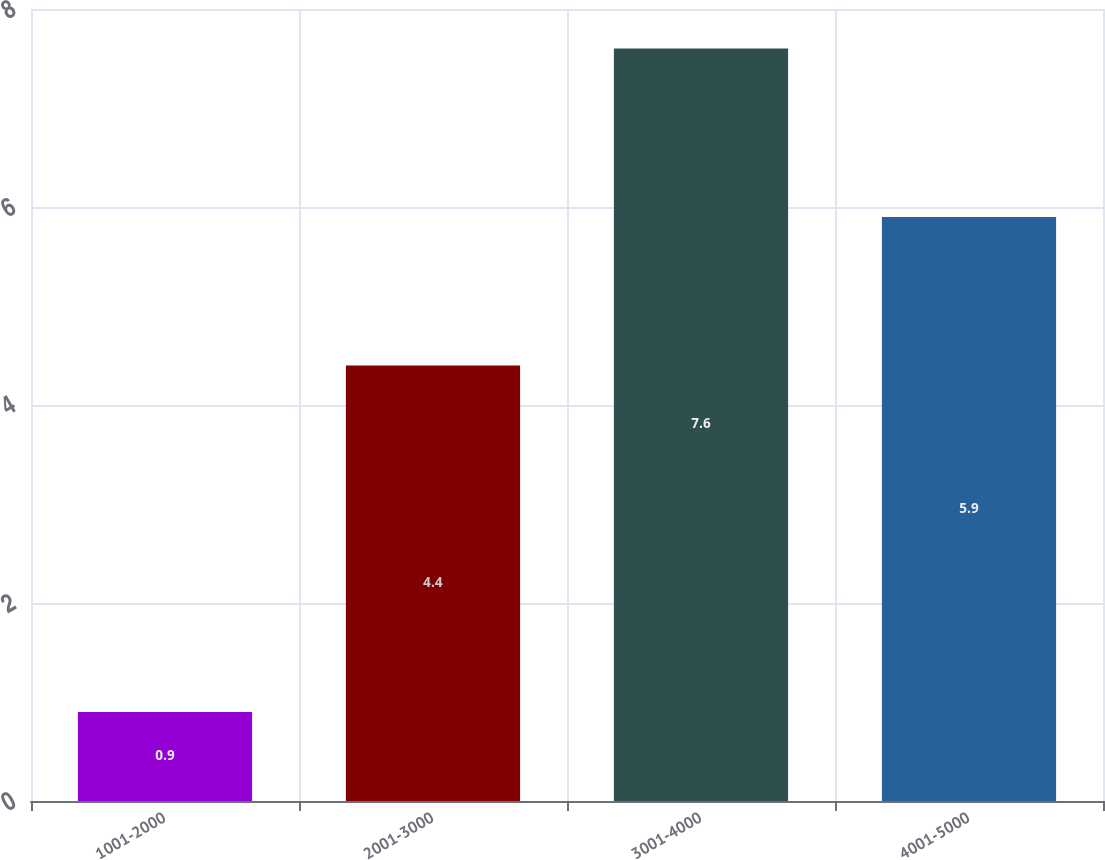<chart> <loc_0><loc_0><loc_500><loc_500><bar_chart><fcel>1001-2000<fcel>2001-3000<fcel>3001-4000<fcel>4001-5000<nl><fcel>0.9<fcel>4.4<fcel>7.6<fcel>5.9<nl></chart> 